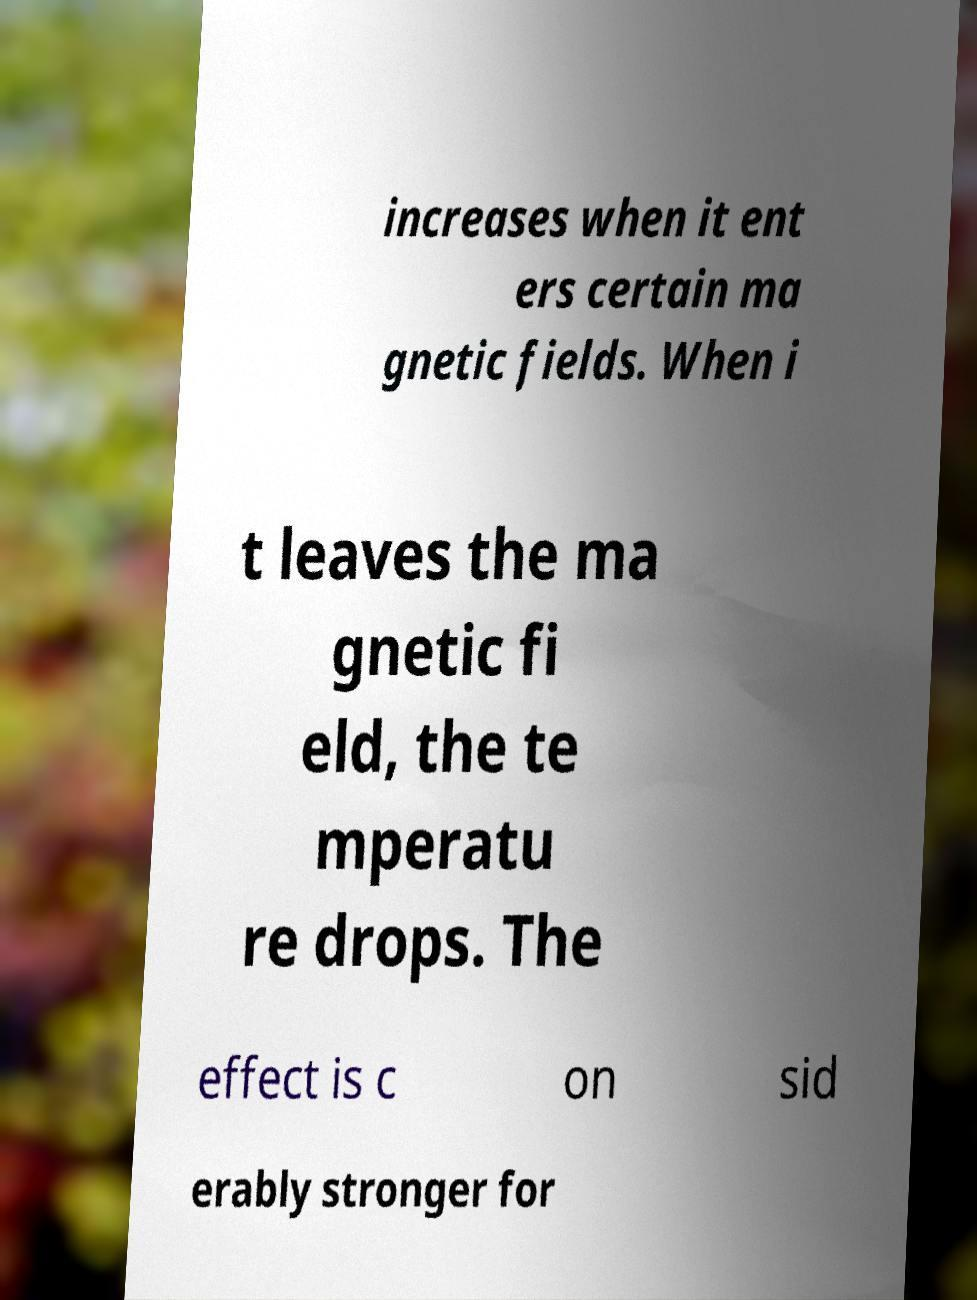Please read and relay the text visible in this image. What does it say? increases when it ent ers certain ma gnetic fields. When i t leaves the ma gnetic fi eld, the te mperatu re drops. The effect is c on sid erably stronger for 